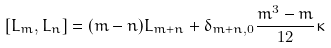<formula> <loc_0><loc_0><loc_500><loc_500>[ L _ { m } , L _ { n } ] = ( m - n ) L _ { m + n } + \delta _ { m + n , 0 } \frac { m ^ { 3 } - m } { 1 2 } \kappa</formula> 